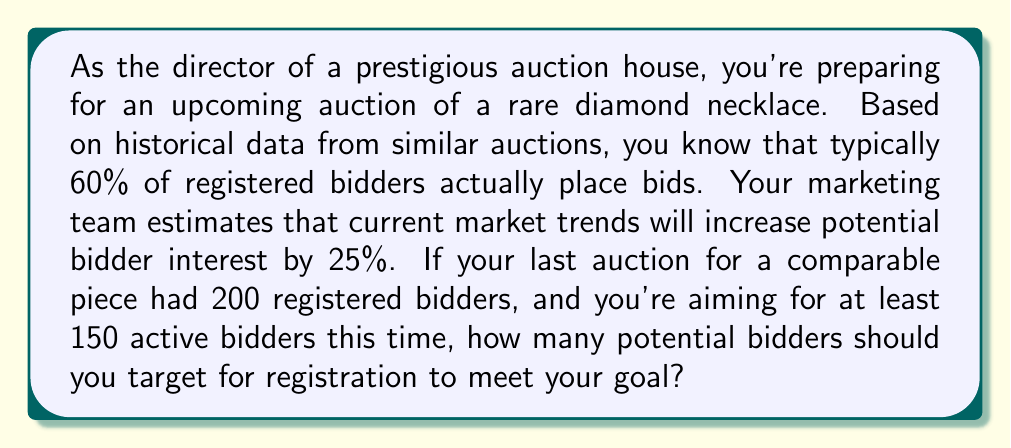Provide a solution to this math problem. Let's approach this step-by-step:

1) First, let's define our variables:
   $x$ = number of potential bidders to target for registration
   $y$ = number of active bidders

2) We know that typically 60% of registered bidders place bids. This can be expressed as:
   $y = 0.6x$

3) However, market trends are expected to increase interest by 25%. This means we should adjust our equation:
   $y = 0.6x \times 1.25 = 0.75x$

4) We want at least 150 active bidders, so we can set up the inequality:
   $0.75x \geq 150$

5) Solving for $x$:
   $x \geq \frac{150}{0.75} = 200$

6) Therefore, we need to target at least 200 potential bidders for registration.

7) To verify, if we have 200 registered bidders:
   $y = 0.75 \times 200 = 150$ active bidders

This meets our minimum goal. Any number above 200 will exceed the goal of 150 active bidders.
Answer: The auction house should target at least 200 potential bidders for registration to meet the goal of having 150 active bidders. 